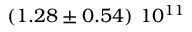<formula> <loc_0><loc_0><loc_500><loc_500>\left ( 1 . 2 8 \pm 0 . 5 4 \right ) \, 1 0 ^ { 1 1 }</formula> 